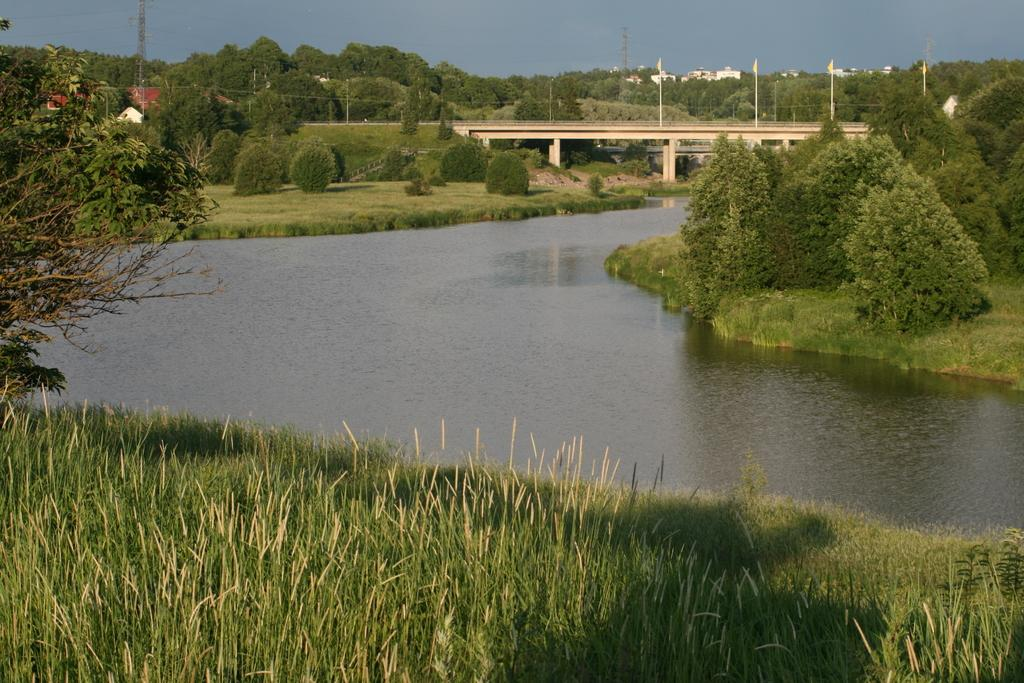What type of vegetation is present in the image? There is grass in the image. What other natural elements can be seen in the image? There are trees in the image. What man-made structure is visible in the image? There is a bridge in the image. What type of decorative elements are present in the image? There are flags in the image. What can be seen in the background of the image? There are buildings in the background of the image. What is visible at the top of the image? The sky is visible at the top of the image. What is the average income of the people living near the bridge in the image? There is no information about the income of people in the image, as it focuses on the natural and man-made elements present. How many pizzas are being served at the event depicted in the image? There is no event or pizzas present in the image; it features a bridge, grass, trees, flags, buildings, and the sky. 